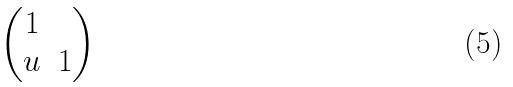<formula> <loc_0><loc_0><loc_500><loc_500>\begin{pmatrix} 1 & \\ u & 1 \end{pmatrix}</formula> 